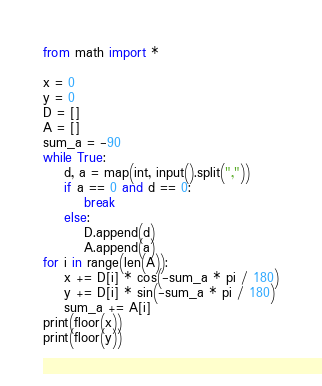<code> <loc_0><loc_0><loc_500><loc_500><_Python_>from math import *

x = 0
y = 0
D = []
A = []
sum_a = -90
while True:
    d, a = map(int, input().split(","))
    if a == 0 and d == 0:
        break
    else:
        D.append(d)
        A.append(a)
for i in range(len(A)):
    x += D[i] * cos(-sum_a * pi / 180)
    y += D[i] * sin(-sum_a * pi / 180)
    sum_a += A[i]
print(floor(x))
print(floor(y))</code> 